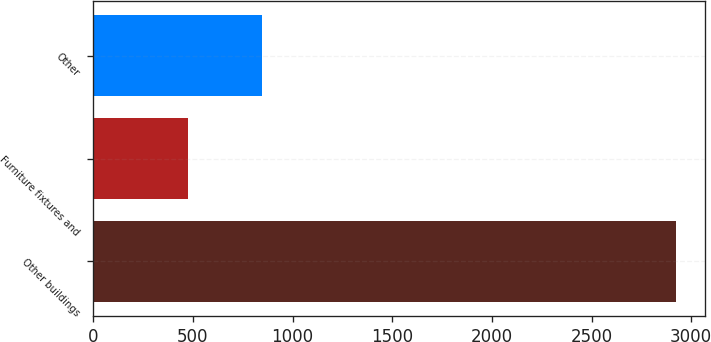<chart> <loc_0><loc_0><loc_500><loc_500><bar_chart><fcel>Other buildings<fcel>Furniture fixtures and<fcel>Other<nl><fcel>2924<fcel>476<fcel>847<nl></chart> 